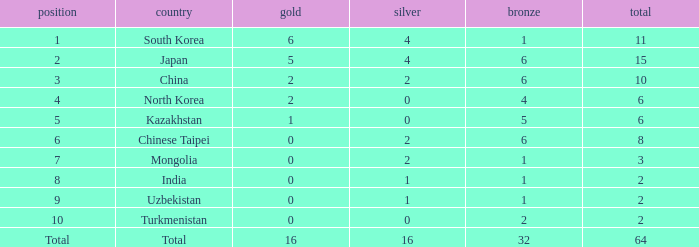How many Golds did Rank 10 get, with a Bronze larger than 2? 0.0. 